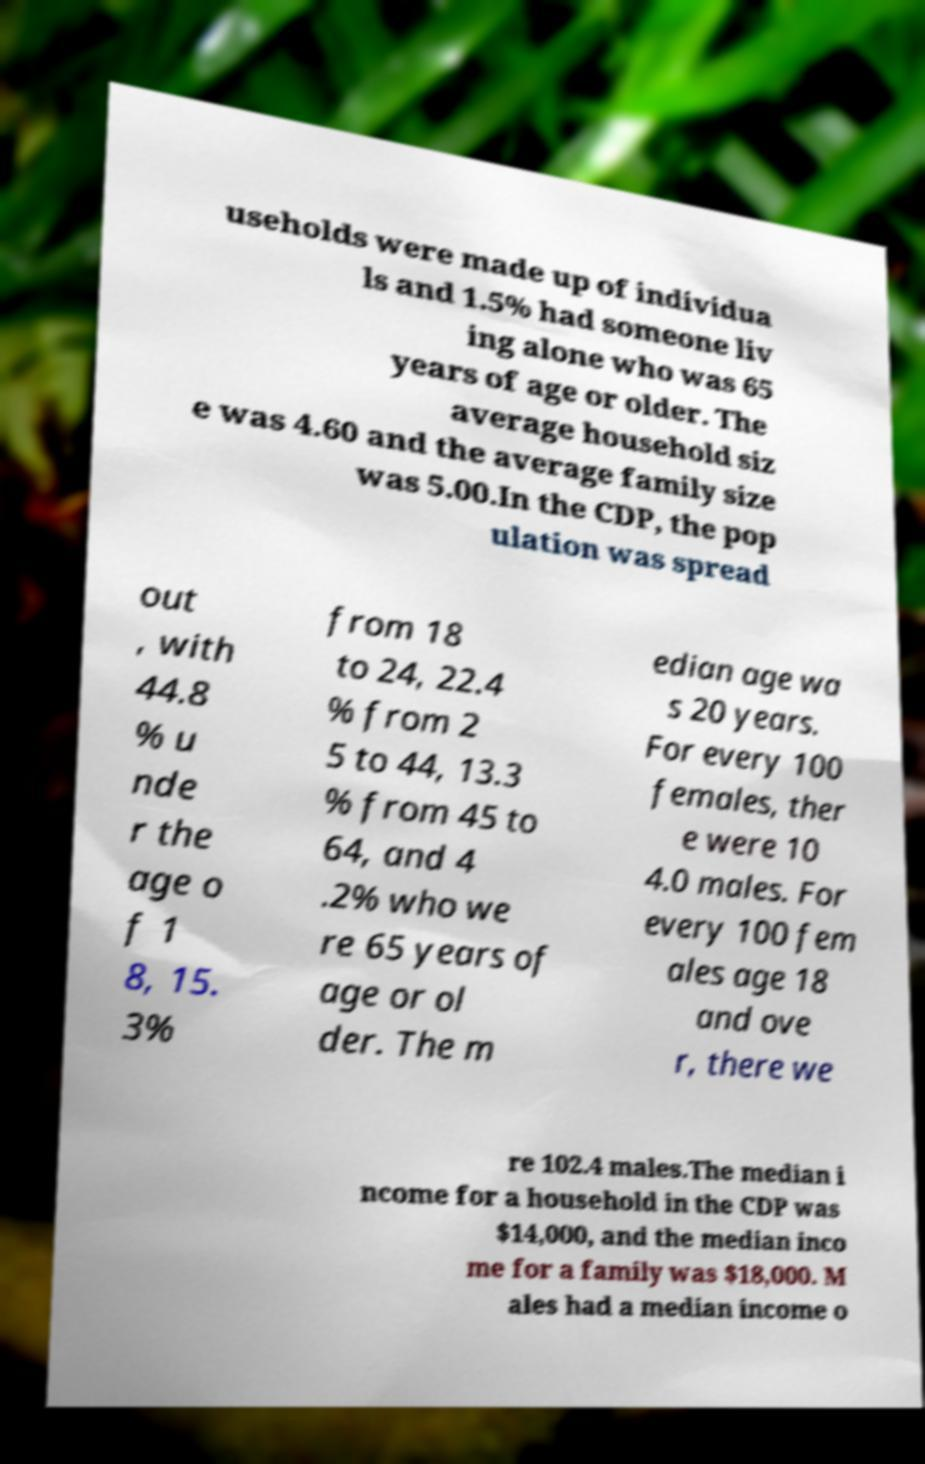Could you extract and type out the text from this image? useholds were made up of individua ls and 1.5% had someone liv ing alone who was 65 years of age or older. The average household siz e was 4.60 and the average family size was 5.00.In the CDP, the pop ulation was spread out , with 44.8 % u nde r the age o f 1 8, 15. 3% from 18 to 24, 22.4 % from 2 5 to 44, 13.3 % from 45 to 64, and 4 .2% who we re 65 years of age or ol der. The m edian age wa s 20 years. For every 100 females, ther e were 10 4.0 males. For every 100 fem ales age 18 and ove r, there we re 102.4 males.The median i ncome for a household in the CDP was $14,000, and the median inco me for a family was $18,000. M ales had a median income o 